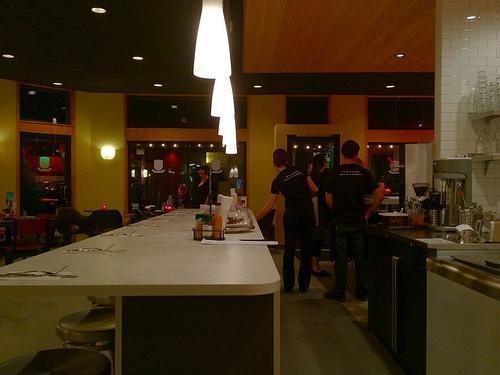How many people are lying on the floor?
Give a very brief answer. 0. How many dinosaurs are in the picture?
Give a very brief answer. 0. How many elephants are pictured?
Give a very brief answer. 0. 